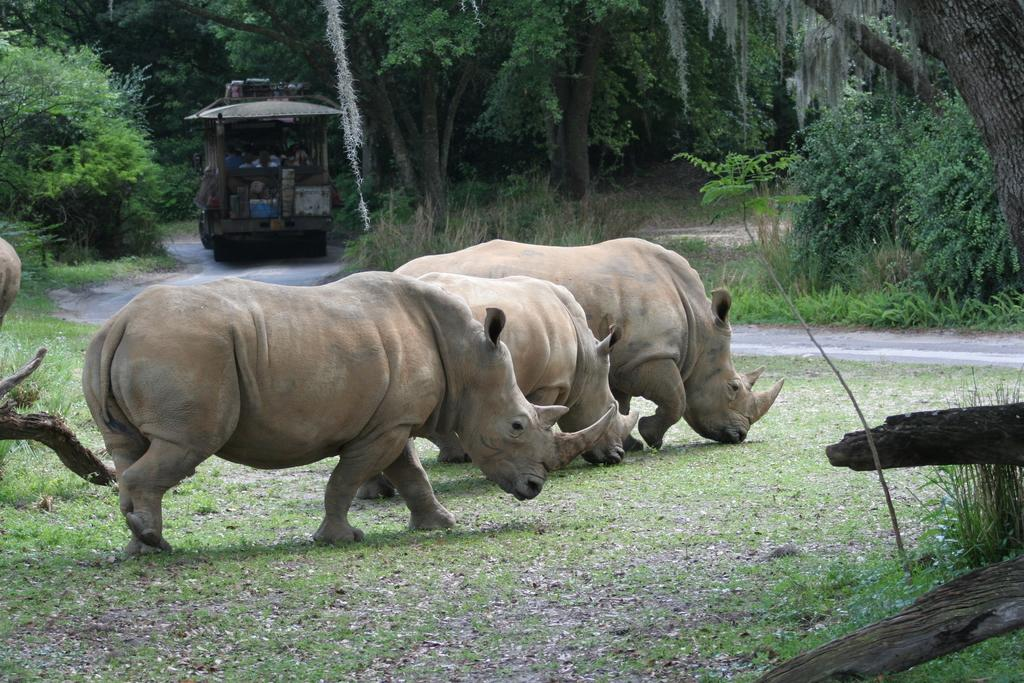What animal is on the path in the image? There is a rhinoceros on the path in the image. What is behind the rhinoceros? There is a vehicle with people behind the rhinoceros. What can be seen in the background of the image? There are trees visible behind the vehicle. What type of fan is visible in the image? There is no fan present in the image. How many tickets are required to ride the rhinoceros in the image? There is no indication of tickets or riding the rhinoceros in the image. 